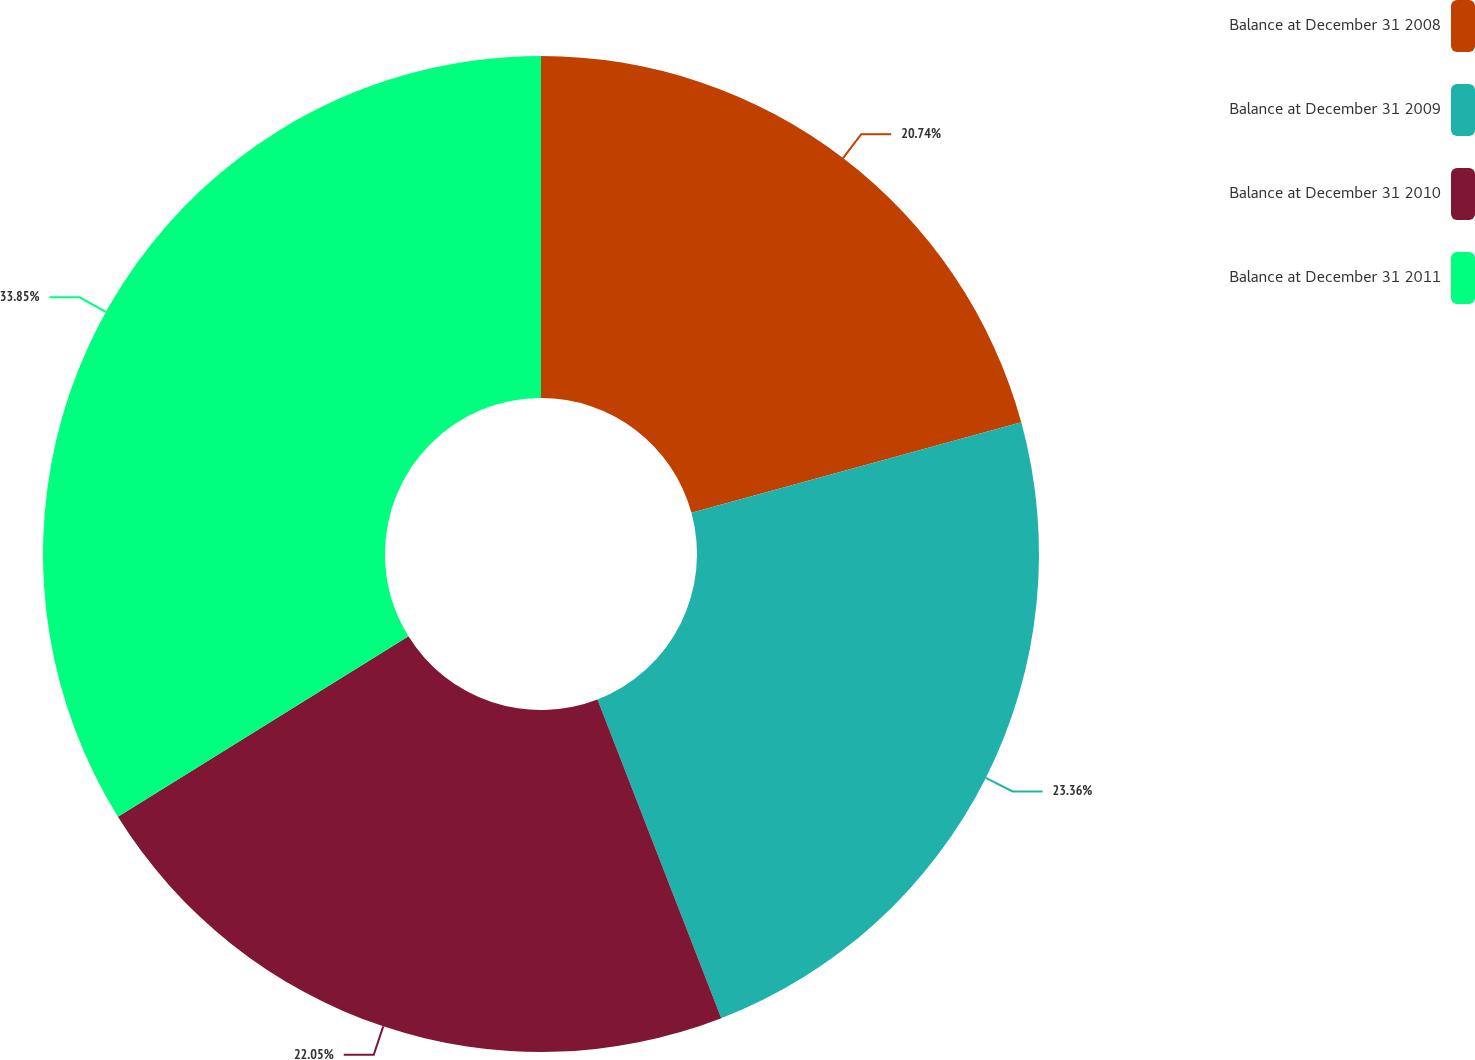Convert chart to OTSL. <chart><loc_0><loc_0><loc_500><loc_500><pie_chart><fcel>Balance at December 31 2008<fcel>Balance at December 31 2009<fcel>Balance at December 31 2010<fcel>Balance at December 31 2011<nl><fcel>20.74%<fcel>23.36%<fcel>22.05%<fcel>33.84%<nl></chart> 